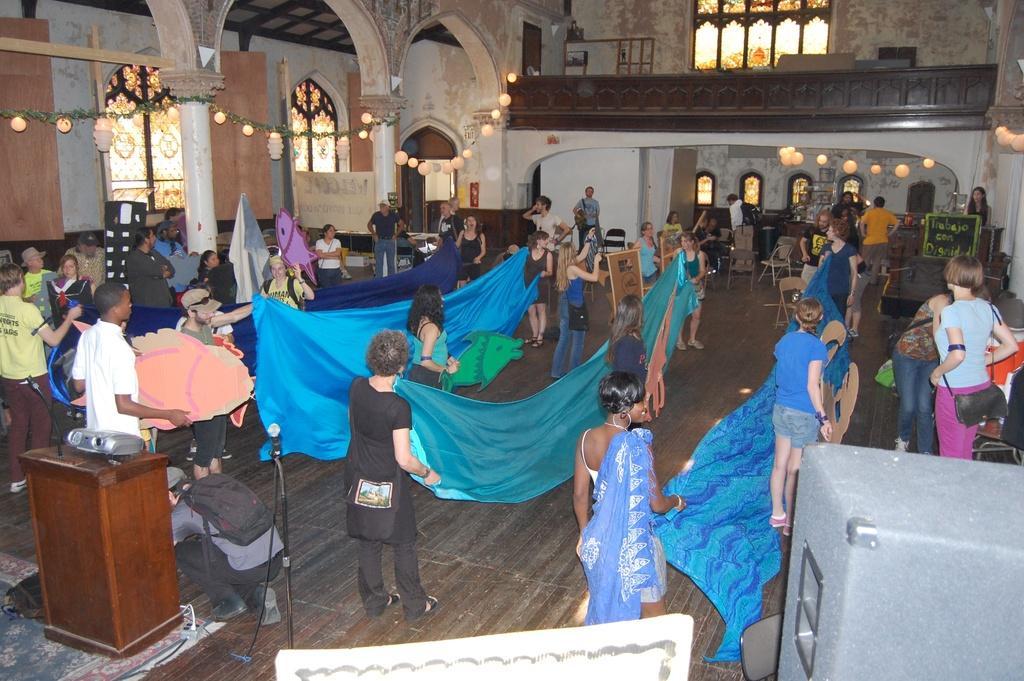Can you describe this image briefly? In this image in the front there are persons standing and there are some persons holding cloth. In the front on the left side there is a podium and on the podium there is a mic and there is a projector and there is a mic with a stand. On the right side there is an object which is grey in colour. In the background there are windows, there are lights, there is a railing and there are pillows and there is a wall, there are empty chairs and there are persons sitting on the chair and there are boards with some text written on it. 